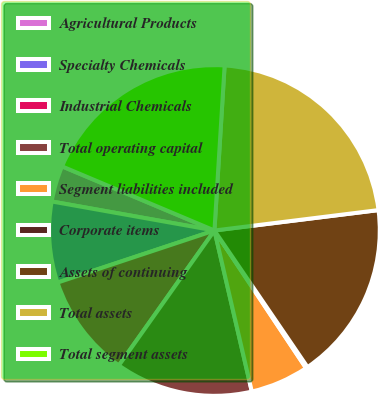<chart> <loc_0><loc_0><loc_500><loc_500><pie_chart><fcel>Agricultural Products<fcel>Specialty Chemicals<fcel>Industrial Chemicals<fcel>Total operating capital<fcel>Segment liabilities included<fcel>Corporate items<fcel>Assets of continuing<fcel>Total assets<fcel>Total segment assets<nl><fcel>3.53%<fcel>7.91%<fcel>10.09%<fcel>13.44%<fcel>5.72%<fcel>0.17%<fcel>17.45%<fcel>22.05%<fcel>19.64%<nl></chart> 